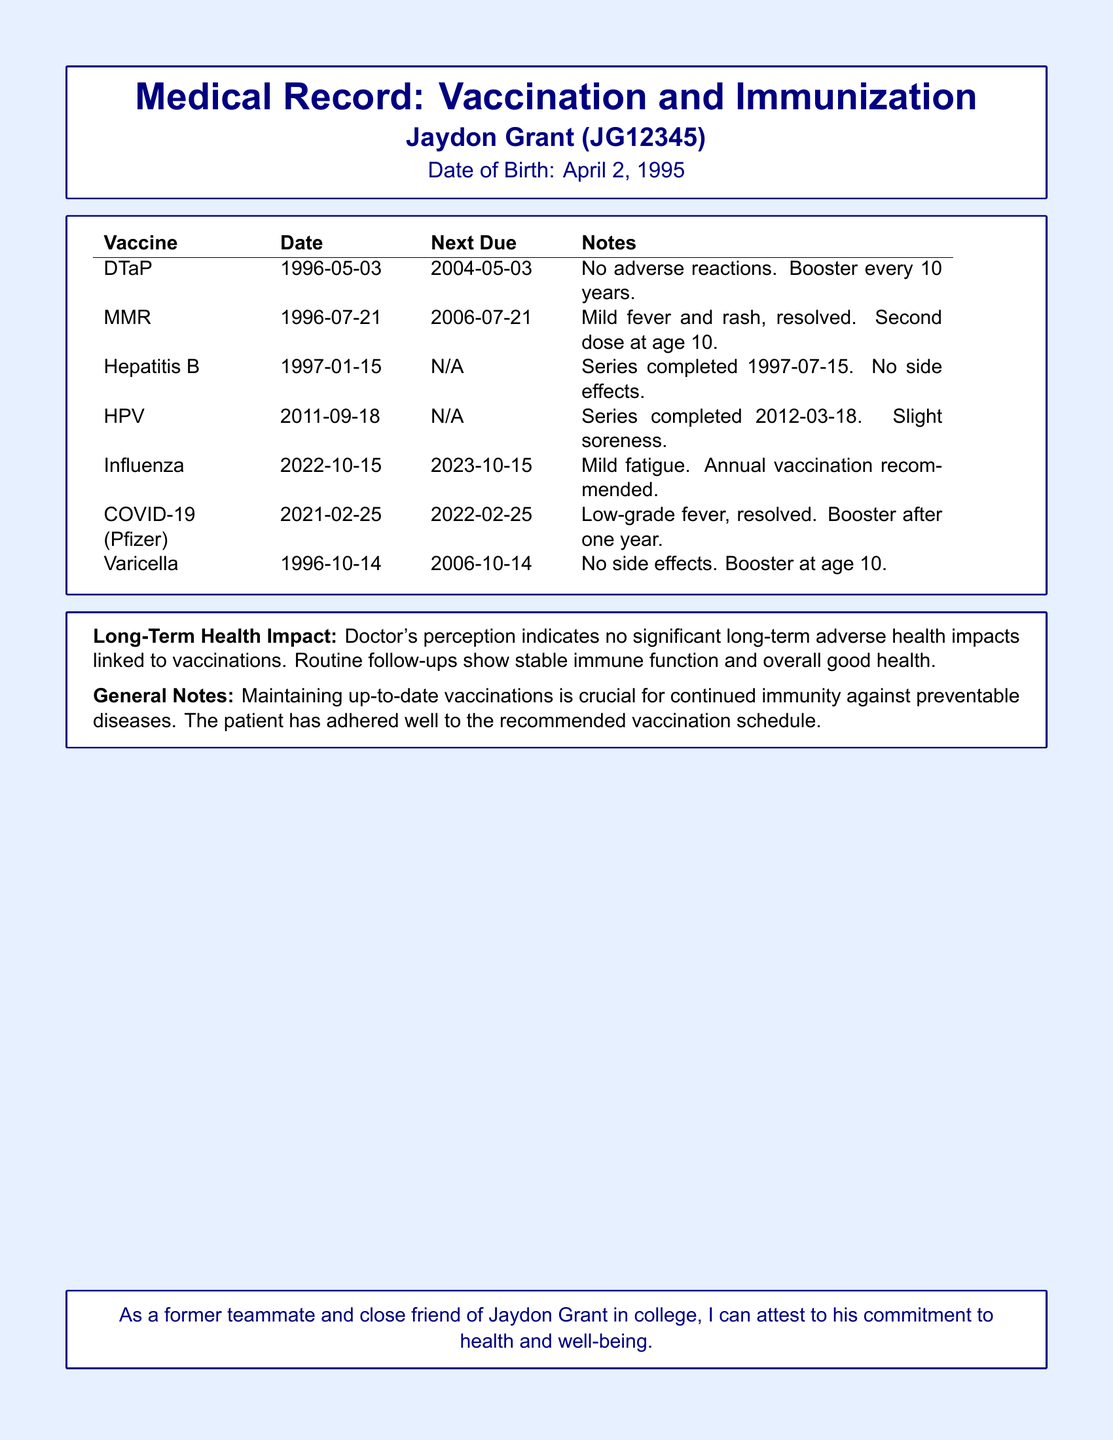What vaccines were administered? The document lists the vaccines administered, including DTaP, MMR, Hepatitis B, HPV, Influenza, COVID-19 (Pfizer), and Varicella.
Answer: DTaP, MMR, Hepatitis B, HPV, Influenza, COVID-19 (Pfizer), Varicella What is the next due date for the MMR vaccine? The document specifies the next due date for the MMR vaccine as July 21, 2006.
Answer: 2006-07-21 What adverse reactions were noted for the influenza vaccination? The document mentions that the patient experienced mild fatigue as an adverse reaction to the influenza vaccination.
Answer: Mild fatigue What is the doctor's perception of long-term health impacts from vaccinations? The doctor's notes indicate that there are no significant long-term adverse health impacts linked to vaccinations.
Answer: No significant long-term adverse health impacts How often is the influenza vaccination recommended? The document states that the influenza vaccination is recommended annually.
Answer: Annual How old was Jaydon Grant when he received the first dose of the Hepatitis B vaccine? The first dose of the Hepatitis B vaccine was administered on January 15, 1997, when he was 1 year old.
Answer: 1 year old What is the next due date for the DTaP booster? The document states that the next due date for the DTaP booster is May 3, 2004.
Answer: 2004-05-03 What was the immune response after the COVID-19 vaccination? The document notes a low-grade fever that resolved after the COVID-19 vaccination.
Answer: Low-grade fever, resolved What is the purpose of maintaining up-to-date vaccinations according to the general notes? The general notes highlight the importance of maintaining up-to-date vaccinations for continued immunity against preventable diseases.
Answer: Continued immunity against preventable diseases 